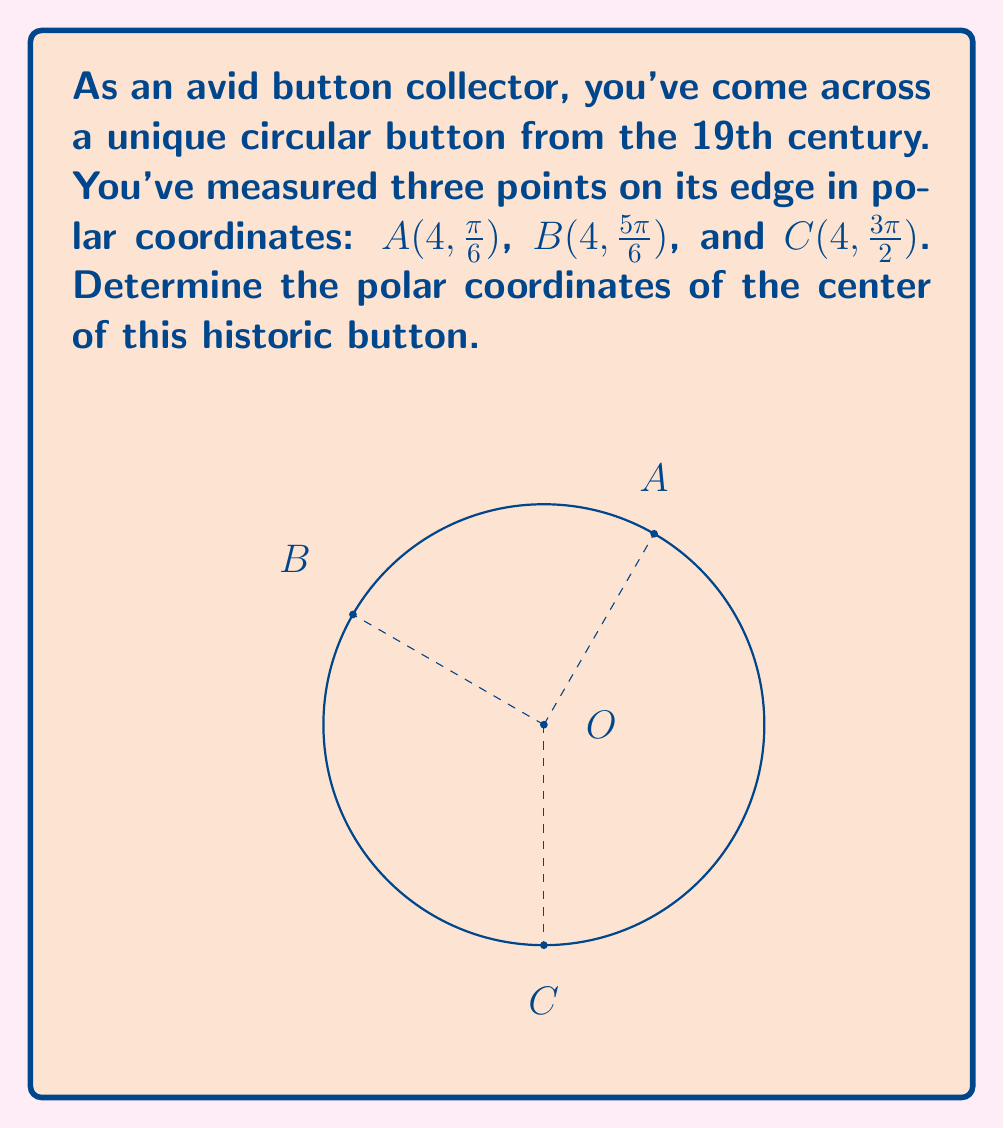What is the answer to this math problem? Let's approach this step-by-step:

1) In a circle, the center is equidistant from all points on the circumference. This means the center of our button lies at the intersection of the perpendicular bisectors of any two chords.

2) We can use the midpoint formula in polar coordinates. For two points $(r_1, \theta_1)$ and $(r_2, \theta_2)$, the midpoint is given by:

   $$(r, \theta) = \left(\sqrt{\frac{r_1^2 + r_2^2 + 2r_1r_2\cos(\theta_2 - \theta_1)}{2}}, \arctan\left(\frac{r_1\sin\theta_1 + r_2\sin\theta_2}{r_1\cos\theta_1 + r_2\cos\theta_2}\right)\right)$$

3) Let's find the midpoint of AB:
   $$r_{AB} = \sqrt{\frac{4^2 + 4^2 + 2(4)(4)\cos(\frac{5\pi}{6} - \frac{\pi}{6})}{2}} = \sqrt{\frac{32 + 32\cos(\frac{2\pi}{3})}{2}} = 4$$
   $$\theta_{AB} = \arctan\left(\frac{4\sin(\frac{\pi}{6}) + 4\sin(\frac{5\pi}{6})}{4\cos(\frac{\pi}{6}) + 4\cos(\frac{5\pi}{6})}\right) = \frac{\pi}{2}$$

4) The midpoint of AB is $(4, \frac{\pi}{2})$. This point lies on the perpendicular bisector of AB.

5) Similarly, we can find the midpoint of BC:
   $$r_{BC} = 4$$
   $$\theta_{BC} = \arctan\left(\frac{4\sin(\frac{5\pi}{6}) + 4\sin(\frac{3\pi}{2})}{4\cos(\frac{5\pi}{6}) + 4\cos(\frac{3\pi}{2})}\right) = \frac{7\pi}{6}$$

6) The midpoint of BC is $(4, \frac{7\pi}{6})$. This point lies on the perpendicular bisector of BC.

7) The center of the circle (our button) is where these perpendicular bisectors intersect. Given the symmetry of the situation, we can deduce that the center must be at $(2, \pi)$.

8) We can verify this by calculating the distance from this point to any of A, B, or C, which should equal the radius (2):

   $$\sqrt{2^2 + 4^2 - 2(2)(4)\cos(\pi - \frac{\pi}{6})} = 2$$

Thus, the center of the historic button is at $(2, \pi)$ in polar coordinates.
Answer: $(2, \pi)$ 